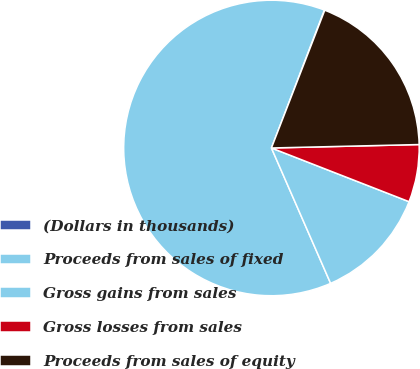<chart> <loc_0><loc_0><loc_500><loc_500><pie_chart><fcel>(Dollars in thousands)<fcel>Proceeds from sales of fixed<fcel>Gross gains from sales<fcel>Gross losses from sales<fcel>Proceeds from sales of equity<nl><fcel>0.05%<fcel>62.39%<fcel>12.52%<fcel>6.29%<fcel>18.75%<nl></chart> 